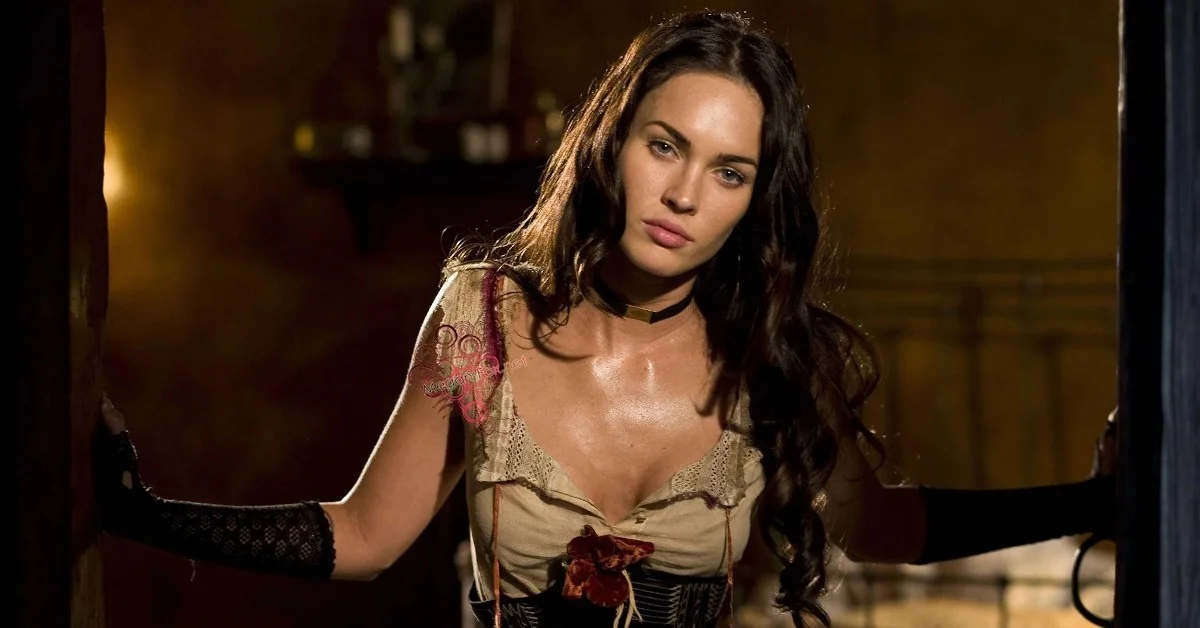Analyze the image in a comprehensive and detailed manner. The image presents a woman standing at a doorway, poised dramatically with her arms extended along the door frame. She wears a historically inspired ensemble featuring a corset detailed with a lace overlay and a decorative red rose at the center, pairing it with long, patterned black gloves. Her attire suggests a stylized period look, possibly for a thematic event or character portrayal in film or theater. Her expression is intense and contemplative, adding to the overall dramatic effect. The setting features a rustic wooden door and a well-worn brick wall, which contributes to the vintage or historical ambiance of the scene. 